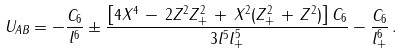<formula> <loc_0><loc_0><loc_500><loc_500>U _ { A B } = - \frac { C _ { 6 } } { l ^ { 6 } } \pm \frac { \left [ 4 X ^ { 4 } \, - \, 2 Z ^ { 2 } Z _ { + } ^ { 2 } \, + \, X ^ { 2 } ( Z _ { + } ^ { 2 } \, + \, Z ^ { 2 } ) \right ] C _ { 6 } } { 3 l ^ { 5 } l _ { + } ^ { 5 } } - \frac { C _ { 6 } } { l _ { + } ^ { 6 } } \, .</formula> 